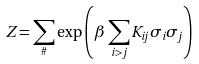Convert formula to latex. <formula><loc_0><loc_0><loc_500><loc_500>Z = \sum _ { \# } \exp \left ( \beta \sum _ { i > j } K _ { i j } \sigma _ { i } \sigma _ { j } \right )</formula> 